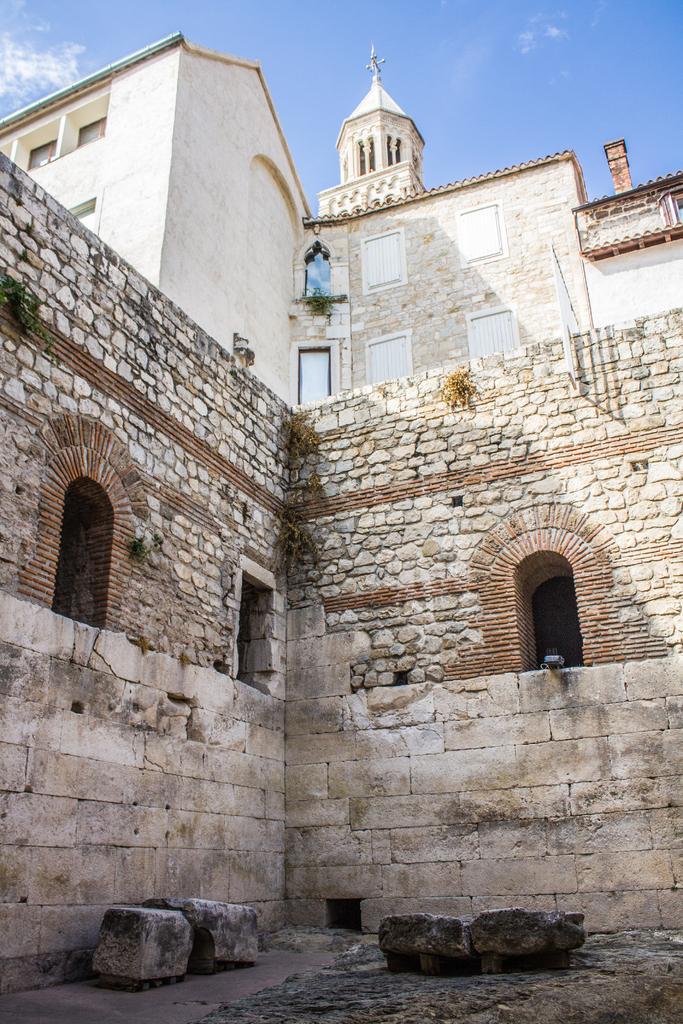Describe this image in one or two sentences. In the picture I can see buildings, rocks, walls and some other objects. In the background I can see the sky. 